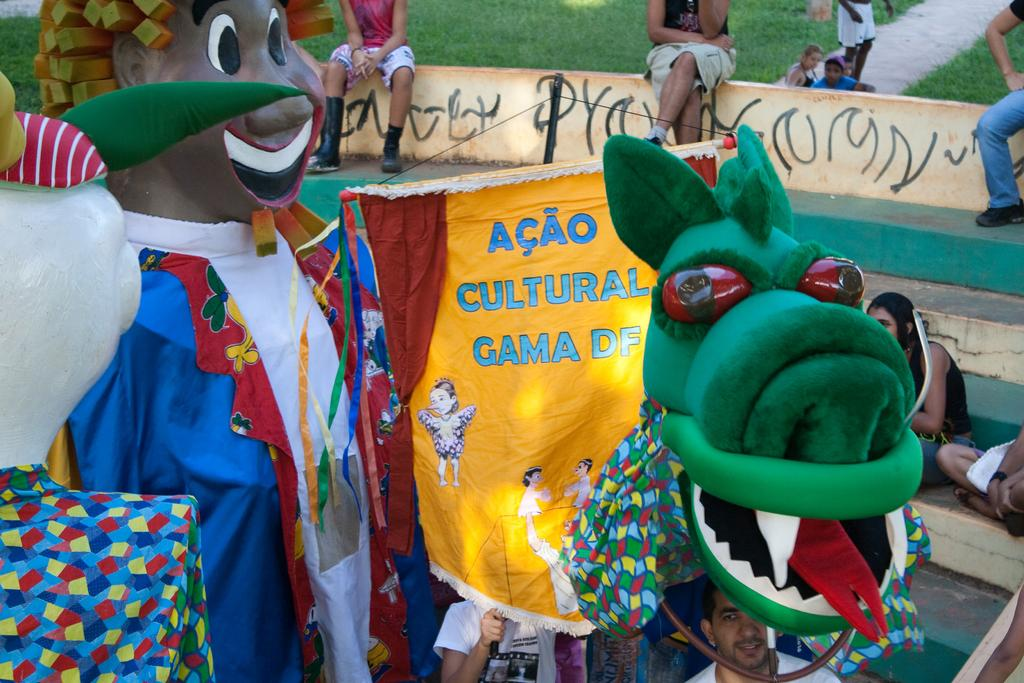Who or what can be seen in the image? There are people in the image. What type of terrain is visible in the image? There is grass in the image. What kind of path is present in the image? There is a pathway in the image. Are there any architectural features in the image? Yes, there are stairs in the image. What else can be found in the image? There are objects and costumes in the image. Is there any text or writing in the image? Yes, there is something written on the wall in the image. What type of machine can be seen in the image? There is no machine present in the image. What shape is the payment in the image? There is no payment or reference to a shape in the image. 